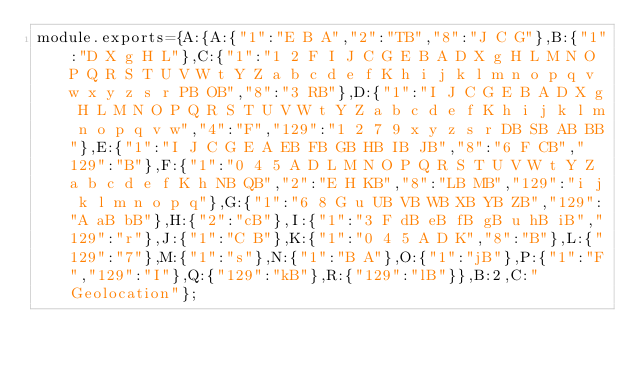<code> <loc_0><loc_0><loc_500><loc_500><_JavaScript_>module.exports={A:{A:{"1":"E B A","2":"TB","8":"J C G"},B:{"1":"D X g H L"},C:{"1":"1 2 F I J C G E B A D X g H L M N O P Q R S T U V W t Y Z a b c d e f K h i j k l m n o p q v w x y z s r PB OB","8":"3 RB"},D:{"1":"I J C G E B A D X g H L M N O P Q R S T U V W t Y Z a b c d e f K h i j k l m n o p q v w","4":"F","129":"1 2 7 9 x y z s r DB SB AB BB"},E:{"1":"I J C G E A EB FB GB HB IB JB","8":"6 F CB","129":"B"},F:{"1":"0 4 5 A D L M N O P Q R S T U V W t Y Z a b c d e f K h NB QB","2":"E H KB","8":"LB MB","129":"i j k l m n o p q"},G:{"1":"6 8 G u UB VB WB XB YB ZB","129":"A aB bB"},H:{"2":"cB"},I:{"1":"3 F dB eB fB gB u hB iB","129":"r"},J:{"1":"C B"},K:{"1":"0 4 5 A D K","8":"B"},L:{"129":"7"},M:{"1":"s"},N:{"1":"B A"},O:{"1":"jB"},P:{"1":"F","129":"I"},Q:{"129":"kB"},R:{"129":"lB"}},B:2,C:"Geolocation"};
</code> 